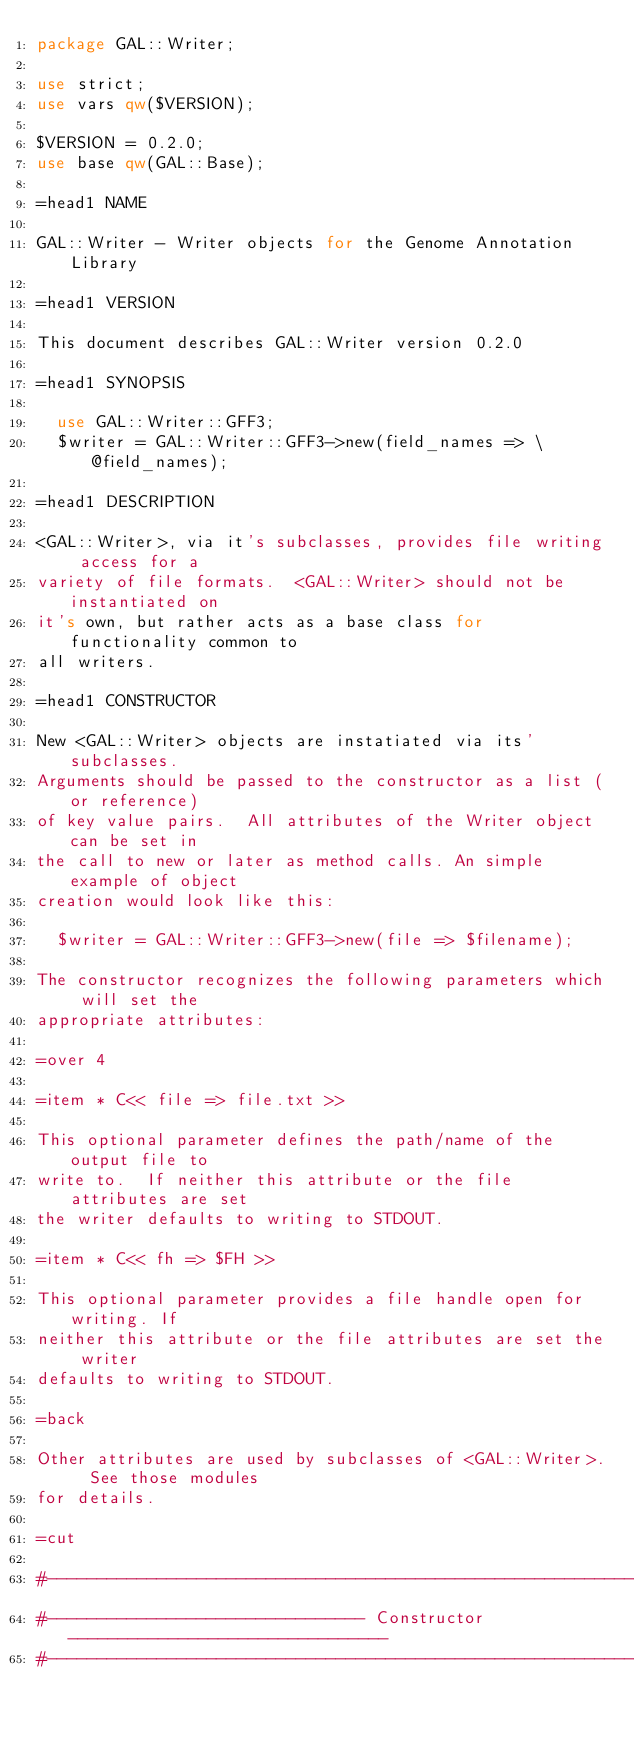Convert code to text. <code><loc_0><loc_0><loc_500><loc_500><_Perl_>package GAL::Writer;

use strict;
use vars qw($VERSION);

$VERSION = 0.2.0;
use base qw(GAL::Base);

=head1 NAME

GAL::Writer - Writer objects for the Genome Annotation Library

=head1 VERSION

This document describes GAL::Writer version 0.2.0

=head1 SYNOPSIS

  use GAL::Writer::GFF3;
  $writer = GAL::Writer::GFF3->new(field_names => \@field_names);

=head1 DESCRIPTION

<GAL::Writer>, via it's subclasses, provides file writing access for a
variety of file formats.  <GAL::Writer> should not be instantiated on
it's own, but rather acts as a base class for functionality common to
all writers.

=head1 CONSTRUCTOR

New <GAL::Writer> objects are instatiated via its' subclasses.
Arguments should be passed to the constructor as a list (or reference)
of key value pairs.  All attributes of the Writer object can be set in
the call to new or later as method calls. An simple example of object
creation would look like this:

  $writer = GAL::Writer::GFF3->new(file => $filename);

The constructor recognizes the following parameters which will set the
appropriate attributes:

=over 4

=item * C<< file => file.txt >>

This optional parameter defines the path/name of the output file to
write to.  If neither this attribute or the file attributes are set
the writer defaults to writing to STDOUT.

=item * C<< fh => $FH >>

This optional parameter provides a file handle open for writing. If
neither this attribute or the file attributes are set the writer
defaults to writing to STDOUT.

=back

Other attributes are used by subclasses of <GAL::Writer>.  See those modules
for details.

=cut

#-----------------------------------------------------------------------------
#-------------------------------- Constructor --------------------------------
#-----------------------------------------------------------------------------
</code> 